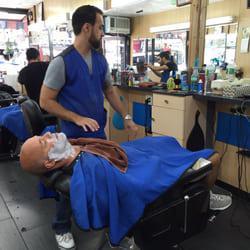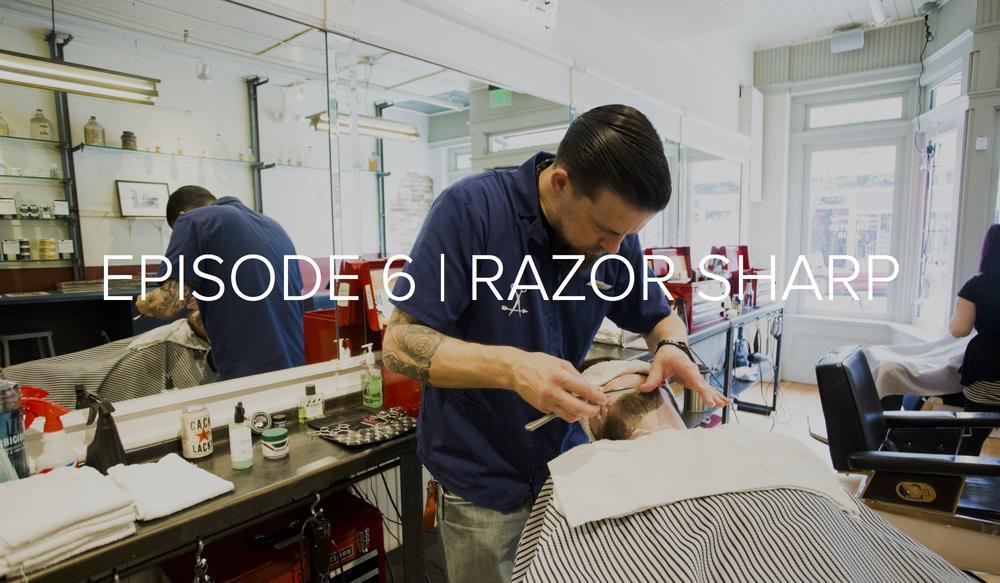The first image is the image on the left, the second image is the image on the right. Assess this claim about the two images: "Foreground of an image shows a barber in blue by an adult male customer draped in blue.". Correct or not? Answer yes or no. Yes. The first image is the image on the left, the second image is the image on the right. Given the left and right images, does the statement "In the right image, there are two people looking straight ahead." hold true? Answer yes or no. No. 